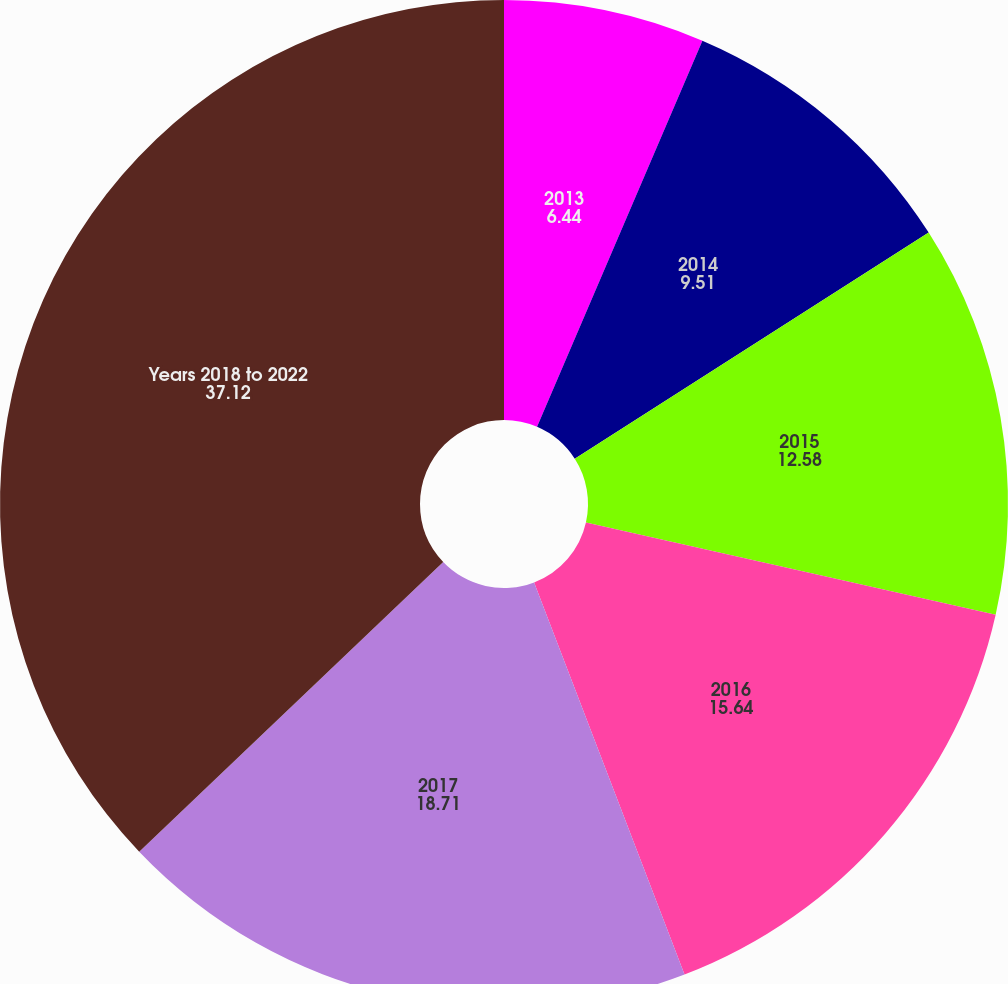Convert chart to OTSL. <chart><loc_0><loc_0><loc_500><loc_500><pie_chart><fcel>2013<fcel>2014<fcel>2015<fcel>2016<fcel>2017<fcel>Years 2018 to 2022<nl><fcel>6.44%<fcel>9.51%<fcel>12.58%<fcel>15.64%<fcel>18.71%<fcel>37.12%<nl></chart> 